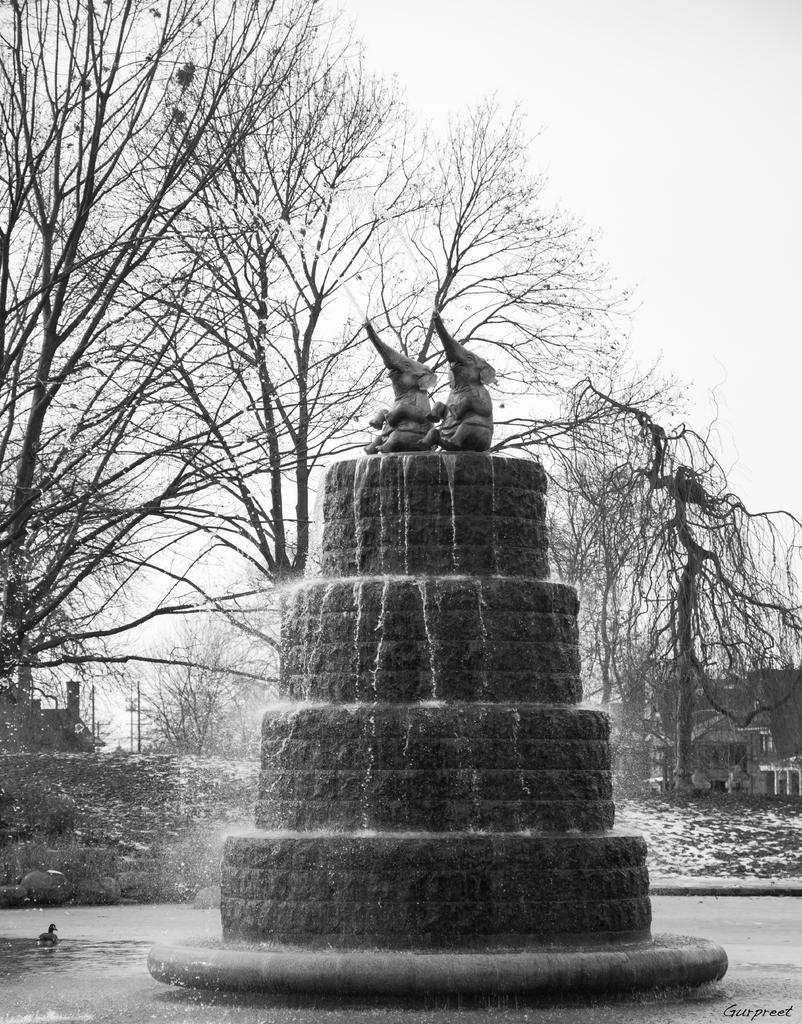Describe this image in one or two sentences. In the center of the image, we can see a fountain and in the background, there are trees. At the bottom, there is water. 